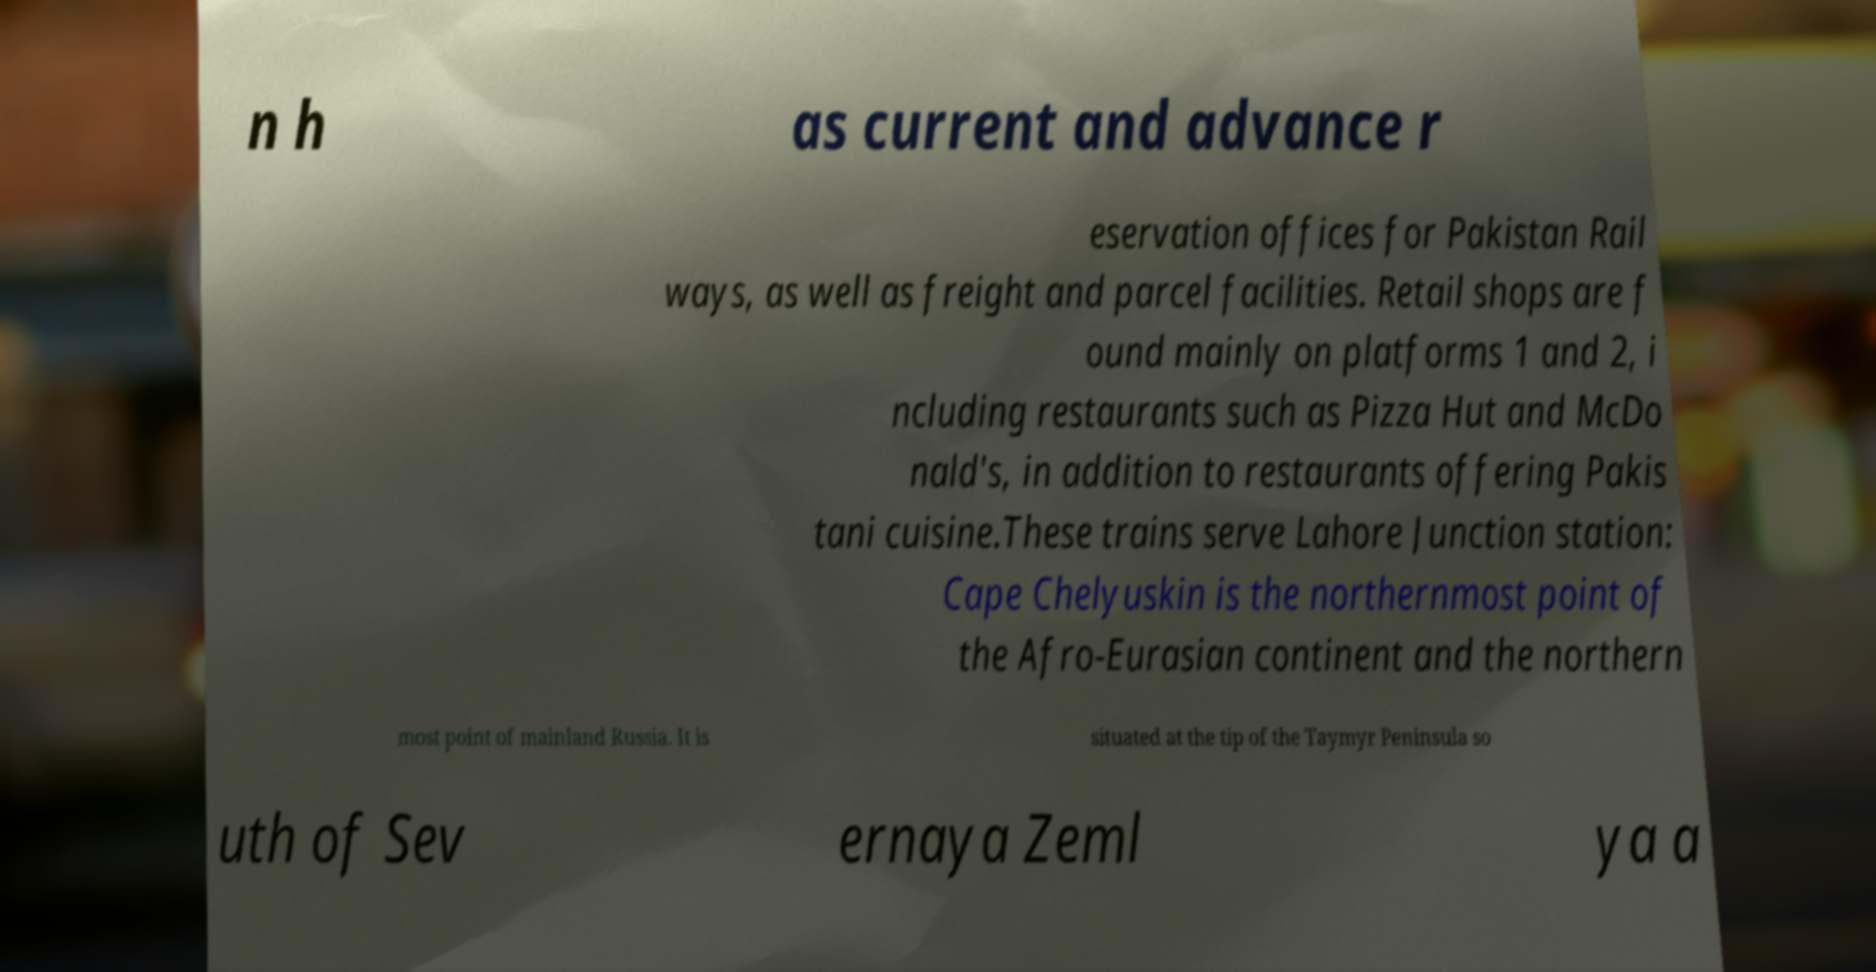Please read and relay the text visible in this image. What does it say? n h as current and advance r eservation offices for Pakistan Rail ways, as well as freight and parcel facilities. Retail shops are f ound mainly on platforms 1 and 2, i ncluding restaurants such as Pizza Hut and McDo nald's, in addition to restaurants offering Pakis tani cuisine.These trains serve Lahore Junction station: Cape Chelyuskin is the northernmost point of the Afro-Eurasian continent and the northern most point of mainland Russia. It is situated at the tip of the Taymyr Peninsula so uth of Sev ernaya Zeml ya a 